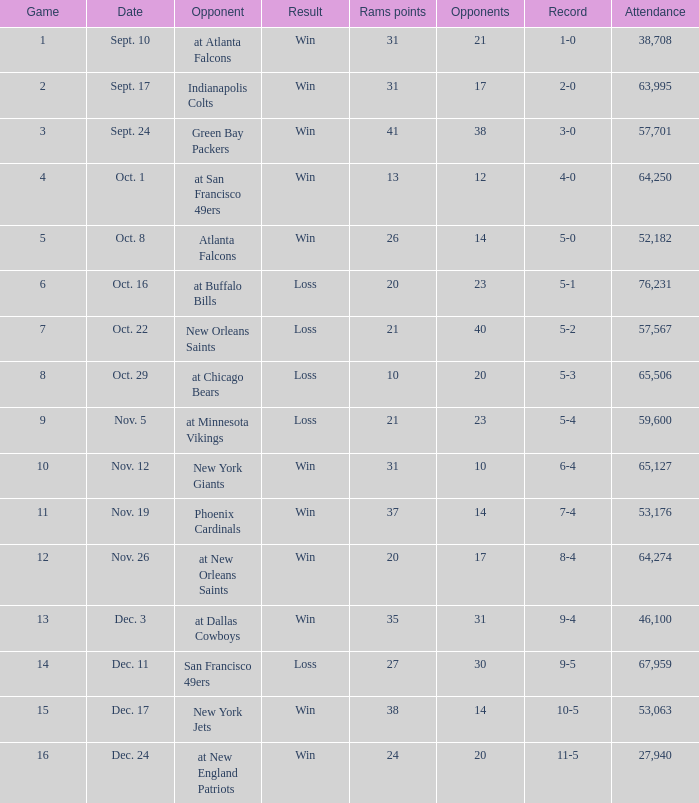What was the number of attendees when the record was 8-4? 64274.0. 